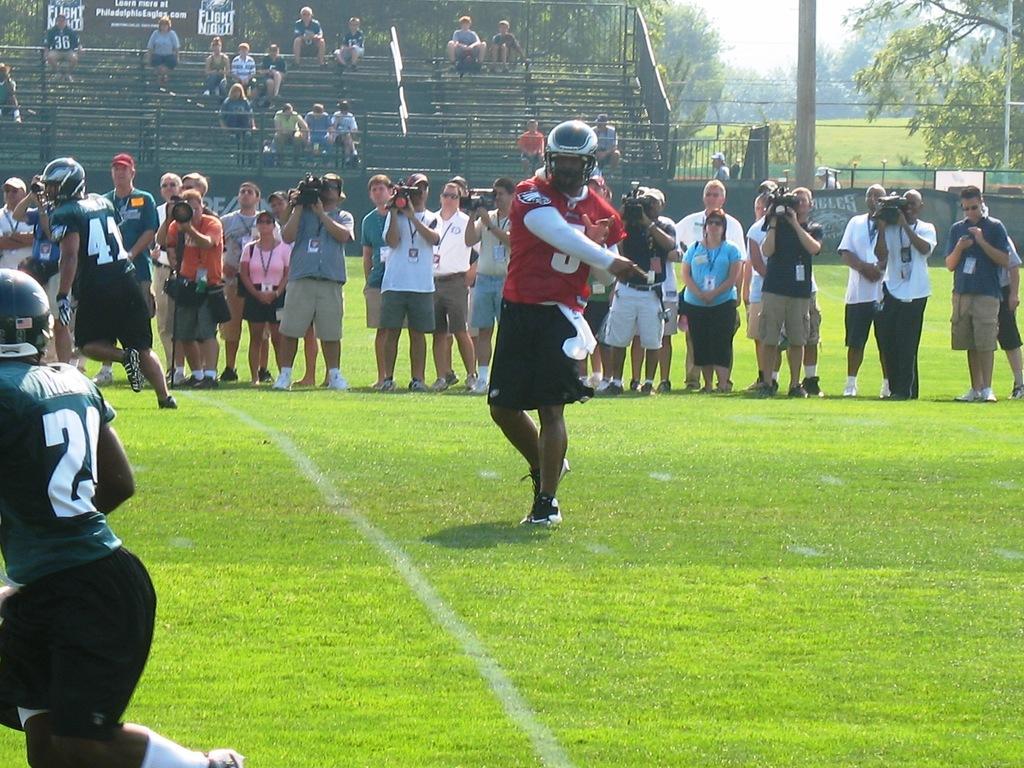Please provide a concise description of this image. In this image I can see a person wearing red, white and black colored dress and helmet is standing. I can see another person wearing green and black colored dress is stunning. In the background I can see number of persons are standing, few of them are holding cameras, few stairs and few persons sitting on them, few trees, the ground and the sky. 